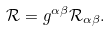Convert formula to latex. <formula><loc_0><loc_0><loc_500><loc_500>\mathcal { R } = g ^ { \alpha \beta } \mathcal { R } _ { \alpha \beta } .</formula> 